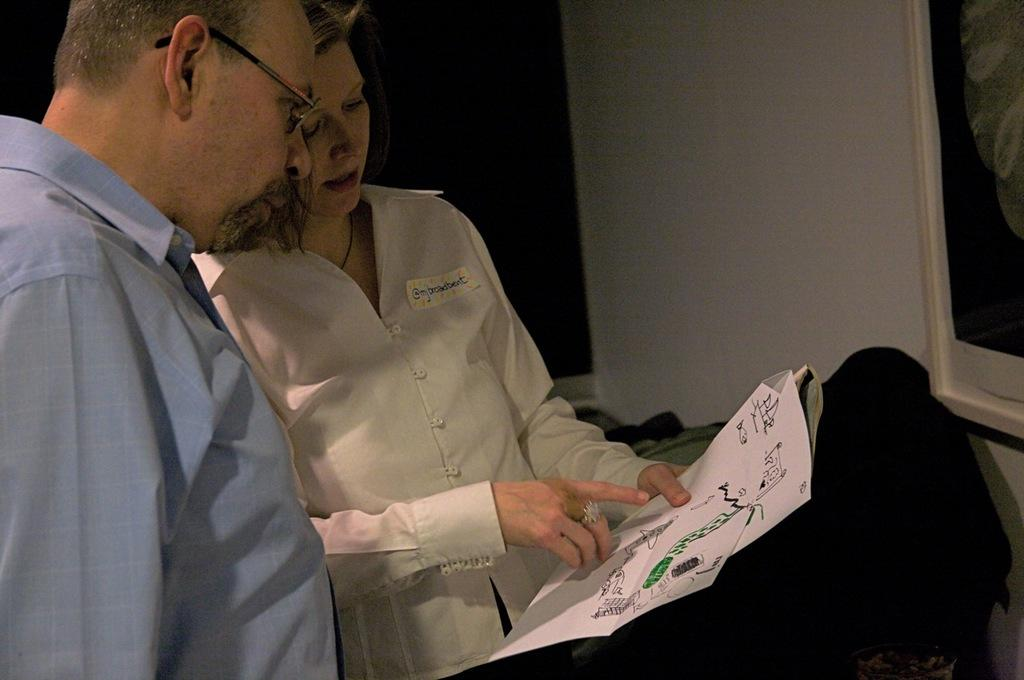Who is present in the image? There is a woman and a man in the image. What is the woman wearing? The woman is wearing a white t-shirt. What is the man wearing? The man is wearing a blue shirt. What is the man holding in the image? The man is holding a paper. What can be seen on the wall on the right side of the image? There is a photo on the wall on the right side of the image. How many bikes are present in the image? There are no bikes present in the image. Does the existence of the photo on the wall prove the existence of a parallel universe? The presence of the photo on the wall does not prove the existence of a parallel universe; it is simply a photo on a wall in the image. 